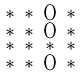<formula> <loc_0><loc_0><loc_500><loc_500>\begin{smallmatrix} * & * & 0 & * \\ * & * & 0 & * \\ * & * & * & * \\ * & * & 0 & * \end{smallmatrix}</formula> 